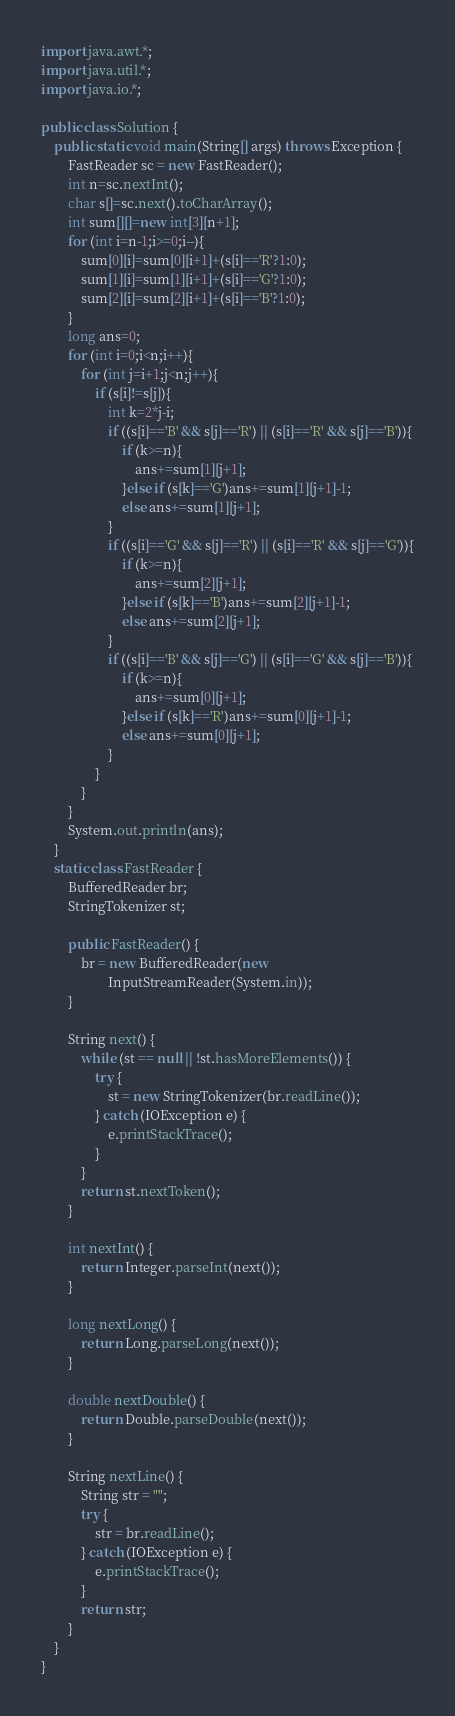<code> <loc_0><loc_0><loc_500><loc_500><_Java_>import java.awt.*;
import java.util.*;
import java.io.*;

public class Solution {
    public static void main(String[] args) throws Exception {
        FastReader sc = new FastReader();
        int n=sc.nextInt();
        char s[]=sc.next().toCharArray();
        int sum[][]=new int[3][n+1];
        for (int i=n-1;i>=0;i--){
            sum[0][i]=sum[0][i+1]+(s[i]=='R'?1:0);
            sum[1][i]=sum[1][i+1]+(s[i]=='G'?1:0);
            sum[2][i]=sum[2][i+1]+(s[i]=='B'?1:0);
        }
        long ans=0;
        for (int i=0;i<n;i++){
            for (int j=i+1;j<n;j++){
                if (s[i]!=s[j]){
                    int k=2*j-i;
                    if ((s[i]=='B' && s[j]=='R') || (s[i]=='R' && s[j]=='B')){
                        if (k>=n){
                            ans+=sum[1][j+1];
                        }else if (s[k]=='G')ans+=sum[1][j+1]-1;
                        else ans+=sum[1][j+1];
                    }
                    if ((s[i]=='G' && s[j]=='R') || (s[i]=='R' && s[j]=='G')){
                        if (k>=n){
                            ans+=sum[2][j+1];
                        }else if (s[k]=='B')ans+=sum[2][j+1]-1;
                        else ans+=sum[2][j+1];
                    }
                    if ((s[i]=='B' && s[j]=='G') || (s[i]=='G' && s[j]=='B')){
                        if (k>=n){
                            ans+=sum[0][j+1];
                        }else if (s[k]=='R')ans+=sum[0][j+1]-1;
                        else ans+=sum[0][j+1];
                    }
                }
            }
        }
        System.out.println(ans);
    }
    static class FastReader {
        BufferedReader br;
        StringTokenizer st;

        public FastReader() {
            br = new BufferedReader(new
                    InputStreamReader(System.in));
        }

        String next() {
            while (st == null || !st.hasMoreElements()) {
                try {
                    st = new StringTokenizer(br.readLine());
                } catch (IOException e) {
                    e.printStackTrace();
                }
            }
            return st.nextToken();
        }

        int nextInt() {
            return Integer.parseInt(next());
        }

        long nextLong() {
            return Long.parseLong(next());
        }

        double nextDouble() {
            return Double.parseDouble(next());
        }

        String nextLine() {
            String str = "";
            try {
                str = br.readLine();
            } catch (IOException e) {
                e.printStackTrace();
            }
            return str;
        }
    }
}</code> 